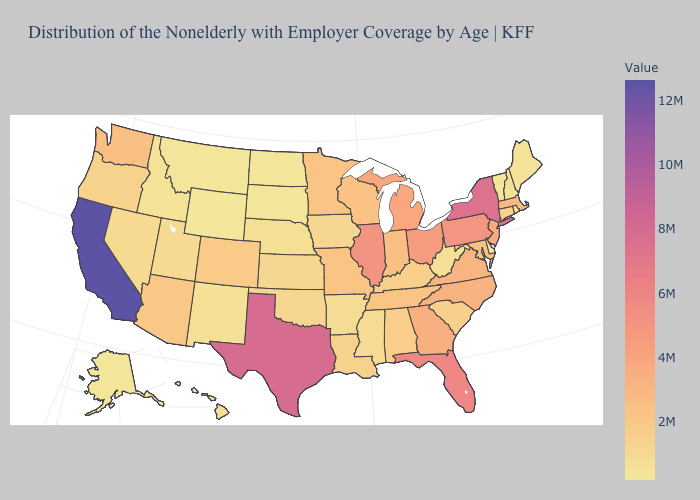Which states have the highest value in the USA?
Short answer required. California. Which states hav the highest value in the MidWest?
Answer briefly. Illinois. Which states have the lowest value in the MidWest?
Answer briefly. North Dakota. Among the states that border Minnesota , does North Dakota have the lowest value?
Be succinct. Yes. Which states have the lowest value in the Northeast?
Keep it brief. Vermont. Among the states that border Pennsylvania , does New Jersey have the lowest value?
Keep it brief. No. 